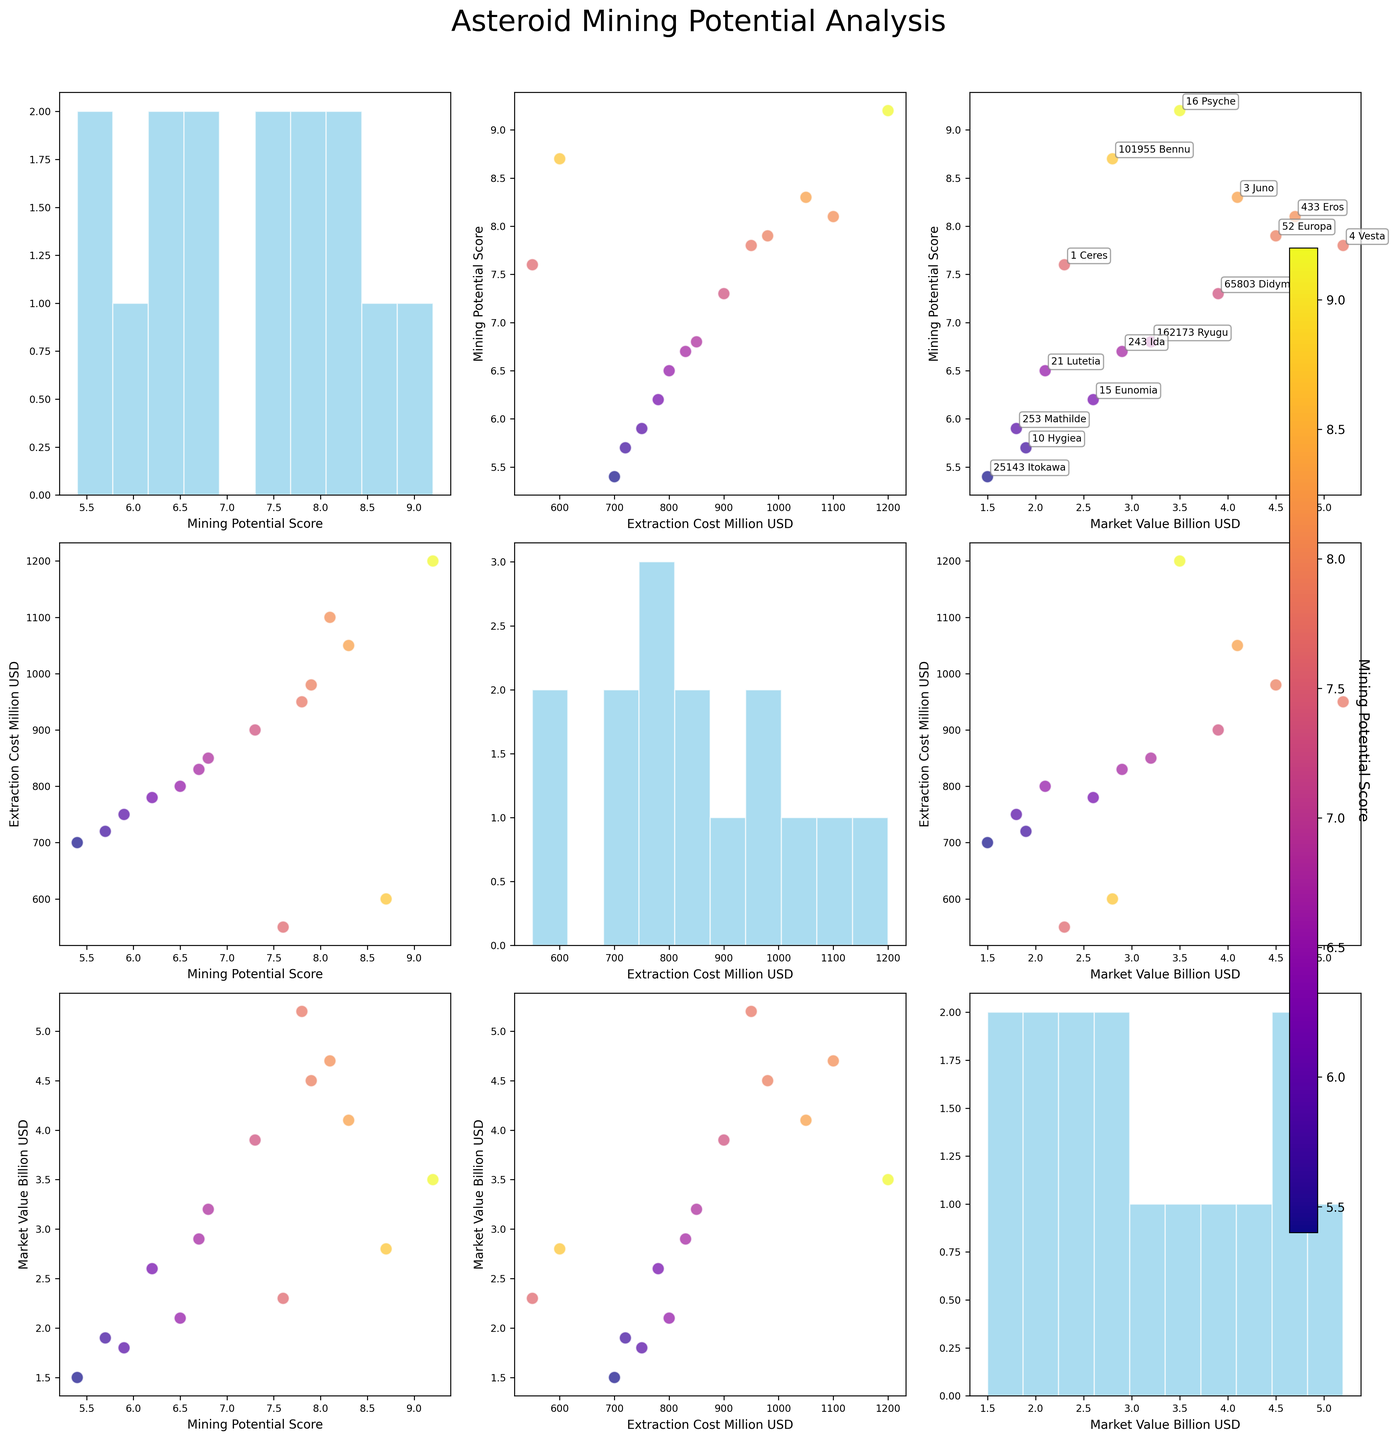How many variables are being compared in the scatterplot matrix? The figure includes three variables: Mining Potential Score, Extraction Cost (Million USD), and Market Value (Billion USD). This is evident from the axes labels and the different pairwise scatterplots shown.
Answer: Three What is the title of the figure? The title of the figure is given at the top of the plot. It reads: "Asteroid Mining Potential Analysis".
Answer: Asteroid Mining Potential Analysis Which asteroid has the highest Mining Potential Score, and what is its score? By looking at the scatterplots and color bar, we can identify 16 Psyche with the highest score, as it has the most intense color (deepest shade). The score is labeled in the scatterplot annotations or can be checked against the color bar.
Answer: 16 Psyche, 9.2 Compare the Market Value and Extraction Cost of 433 Eros and 52 Europa. Which has a higher Market Value and which has a higher Extraction Cost? For Market Value, look at the axis for Market Value (Billion USD) in the scatterplots. 433 Eros has a market value of 4.7 Billion USD, while 52 Europa has a value of 4.5 Billion USD. For Extraction Cost, check the axis for Extraction Cost (Million USD), where 433 Eros has a cost of 1100 Million USD and 52 Europa has a cost of 980 Million USD.
Answer: 433 Eros has a higher Market Value, and 433 Eros has a higher Extraction Cost What's the average Mining Potential Score of the asteroids? Look at the histogram on the diagonal, which represents the distribution of Mining Potential Scores. Sum the individual scores from the figure and divide by the number of asteroids: (9.2 + 7.8 + 6.5 + 5.9 + 8.1 + 7.3 + 8.7 + 6.8 + 5.4 + 7.6 + 8.3 + 6.2 + 5.7 + 7.9 + 6.7) / 15 = 109.1 / 15. Make sure each score and object's name are checked not to miss any data point visually.
Answer: 7.27 Which asteroid has the lowest Extraction Cost and what is its Market Value? Identify the lowest point on the Extraction Cost (Million USD) axis in the scatterplots. 1 Ceres has the lowest Extraction Cost of 550 Million USD. Then look at its corresponding point on the Market Value (Billion USD) axis, which is 2.3 Billion USD. Labels might help in confirming this.
Answer: 1 Ceres, 2.3 Billion USD Is there any asteroid that has both high Mining Potential Score and Extraction Cost? Check scatterplots where both Mining Potential Score and Extraction Cost are compared. 16 Psyche has a high Mining Potential Score of 9.2 and a high Extraction Cost of 1200 Million USD. Both attributes should be high compared to others in their respective axes.
Answer: Yes, 16 Psyche On the scatterplot comparing Market Value and Extraction Cost, which asteroid has the highest Market Value but not the highest Extraction Cost? Focus on the plot with Market Value on one axis and Extraction Cost on the other. 4 Vesta has a high Market Value of 5.2 Billion USD but does not have the highest Extraction Cost (over 1100 Million USD). Instead, it's 950 Million USD. The exact highest can be cross-referenced with annotations.
Answer: 4 Vesta What is the Mining Potential Score for the asteroid with the lowest Market Value? Check the scatterplot or histogram for Market Value where the lowest point is identifiable. 25143 Itokawa has the lowest Market Value of 1.5 Billion USD. Its Mining Potential Score can be cross-referenced with its label or annotation in the figure.
Answer: 5.4 